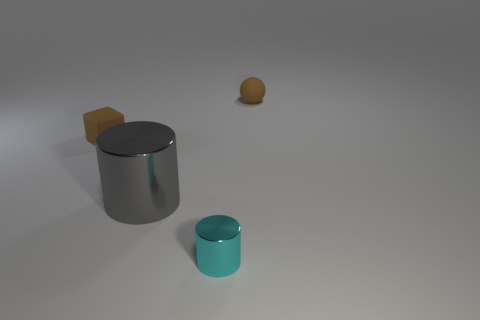What is the material of the small brown thing that is on the left side of the small brown matte thing that is on the right side of the gray metallic cylinder?
Your answer should be compact. Rubber. What number of other things are the same material as the small cyan cylinder?
Ensure brevity in your answer.  1. What material is the cylinder that is the same size as the brown block?
Provide a succinct answer. Metal. Are there more cyan cylinders that are in front of the small brown matte ball than large gray shiny things on the left side of the gray cylinder?
Make the answer very short. Yes. Is there another metallic object that has the same shape as the big gray object?
Provide a succinct answer. Yes. What is the shape of the brown matte object that is the same size as the brown ball?
Your answer should be compact. Cube. The small rubber object on the left side of the gray metal cylinder has what shape?
Make the answer very short. Cube. Are there fewer tiny cyan metallic cylinders left of the large gray shiny thing than cyan shiny cylinders that are behind the tiny brown block?
Keep it short and to the point. No. Is the size of the brown rubber ball the same as the metal cylinder behind the cyan cylinder?
Give a very brief answer. No. What number of rubber balls are the same size as the cyan cylinder?
Offer a terse response. 1. 